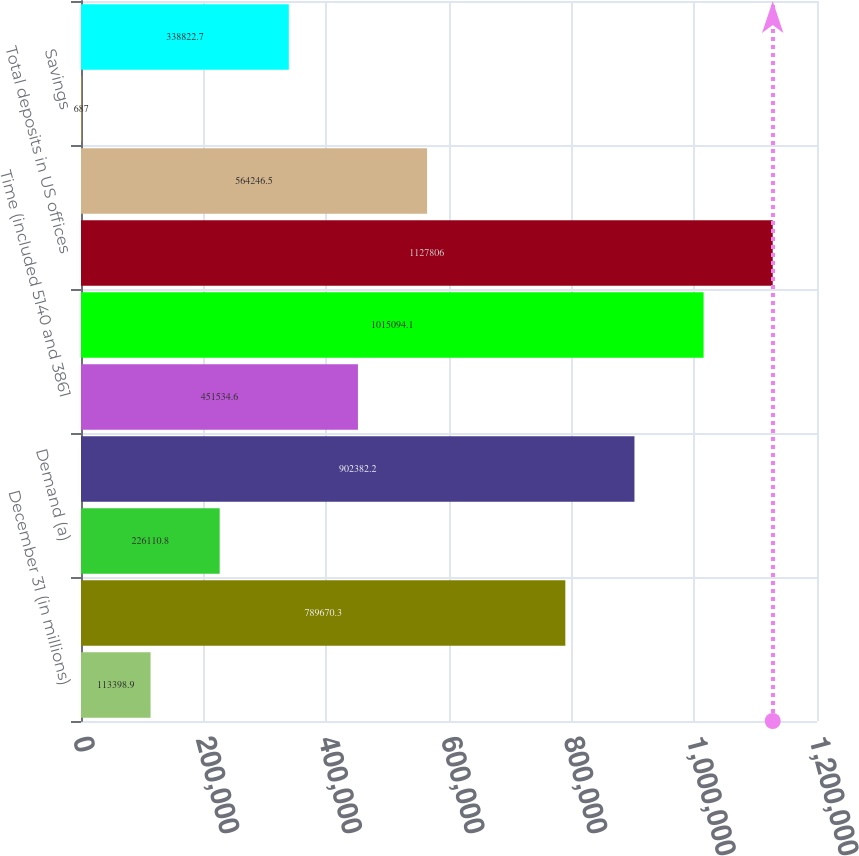<chart> <loc_0><loc_0><loc_500><loc_500><bar_chart><fcel>December 31 (in millions)<fcel>Noninterest-bearing<fcel>Demand (a)<fcel>Savings (b)<fcel>Time (included 5140 and 3861<fcel>Total interest-bearing<fcel>Total deposits in US offices<fcel>Demand<fcel>Savings<fcel>Time (included 593 and 1072 at<nl><fcel>113399<fcel>789670<fcel>226111<fcel>902382<fcel>451535<fcel>1.01509e+06<fcel>1.12781e+06<fcel>564246<fcel>687<fcel>338823<nl></chart> 